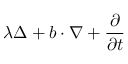<formula> <loc_0><loc_0><loc_500><loc_500>\lambda \Delta + b \cdot \nabla + \frac { \partial } { \partial t }</formula> 